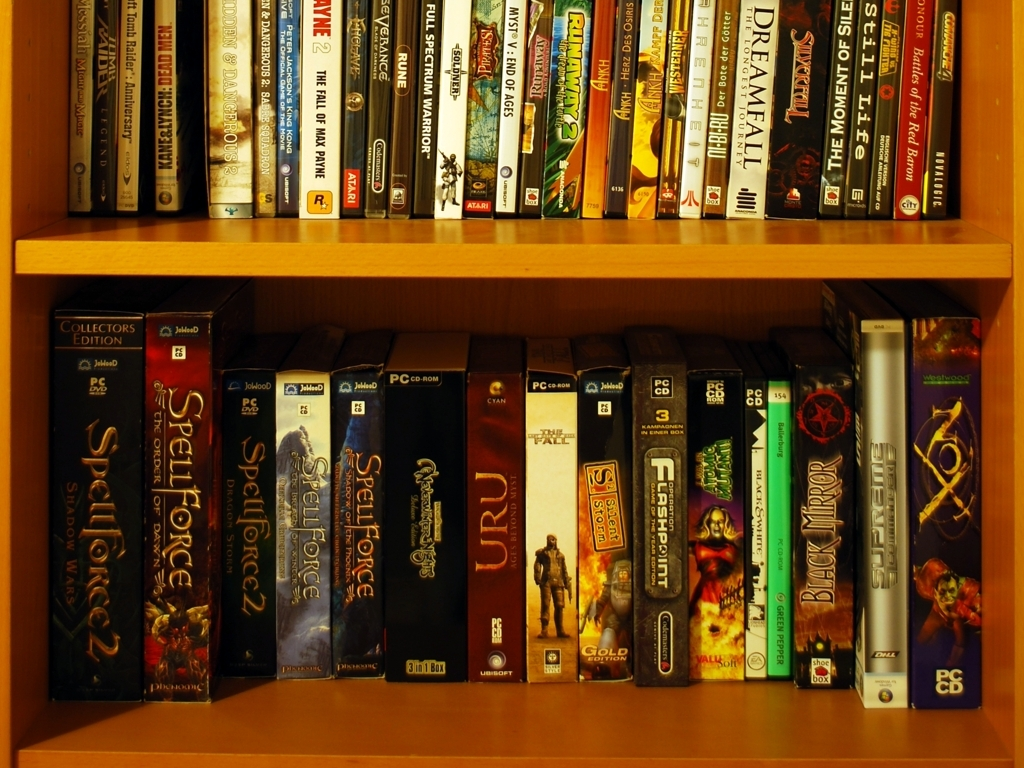Can you tell me more about the genre diversity among the games on this shelf? Certainly! The collection appears to showcase a variety of genres. Titles indicate the presence of role-playing games (RPGs), real-time strategy (RTS) games, and adventure games. This diversity reflects a range of gaming experiences from immersive storytelling and strategic thinking to puzzle-solving and exploration. 